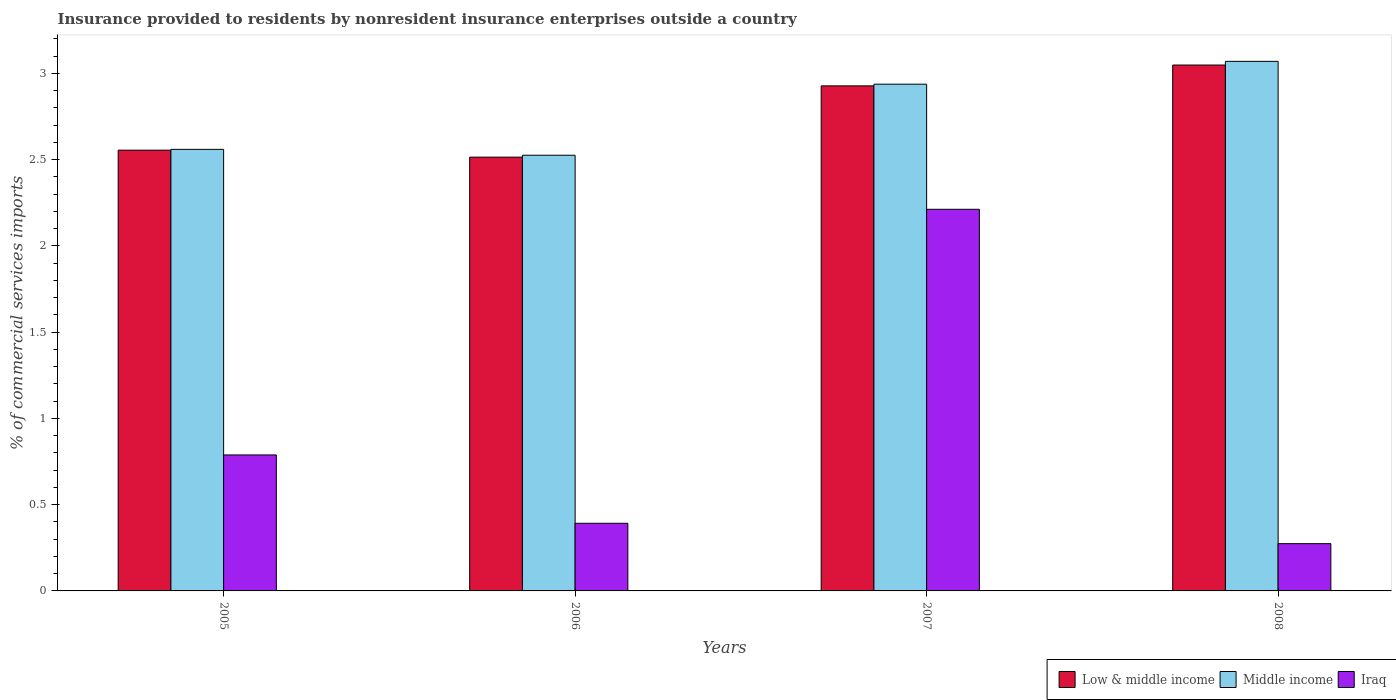Are the number of bars per tick equal to the number of legend labels?
Make the answer very short. Yes. How many bars are there on the 3rd tick from the right?
Offer a very short reply. 3. In how many cases, is the number of bars for a given year not equal to the number of legend labels?
Keep it short and to the point. 0. What is the Insurance provided to residents in Iraq in 2008?
Keep it short and to the point. 0.27. Across all years, what is the maximum Insurance provided to residents in Middle income?
Offer a very short reply. 3.07. Across all years, what is the minimum Insurance provided to residents in Low & middle income?
Your answer should be compact. 2.51. What is the total Insurance provided to residents in Middle income in the graph?
Keep it short and to the point. 11.09. What is the difference between the Insurance provided to residents in Middle income in 2006 and that in 2008?
Provide a succinct answer. -0.54. What is the difference between the Insurance provided to residents in Low & middle income in 2007 and the Insurance provided to residents in Iraq in 2005?
Ensure brevity in your answer.  2.14. What is the average Insurance provided to residents in Low & middle income per year?
Keep it short and to the point. 2.76. In the year 2005, what is the difference between the Insurance provided to residents in Iraq and Insurance provided to residents in Low & middle income?
Offer a very short reply. -1.77. What is the ratio of the Insurance provided to residents in Middle income in 2006 to that in 2007?
Offer a very short reply. 0.86. What is the difference between the highest and the second highest Insurance provided to residents in Low & middle income?
Offer a very short reply. 0.12. What is the difference between the highest and the lowest Insurance provided to residents in Middle income?
Offer a terse response. 0.54. In how many years, is the Insurance provided to residents in Low & middle income greater than the average Insurance provided to residents in Low & middle income taken over all years?
Make the answer very short. 2. Is the sum of the Insurance provided to residents in Iraq in 2007 and 2008 greater than the maximum Insurance provided to residents in Middle income across all years?
Offer a very short reply. No. How many bars are there?
Your response must be concise. 12. How many years are there in the graph?
Offer a terse response. 4. Does the graph contain any zero values?
Your response must be concise. No. Does the graph contain grids?
Ensure brevity in your answer.  No. How many legend labels are there?
Provide a short and direct response. 3. How are the legend labels stacked?
Your answer should be very brief. Horizontal. What is the title of the graph?
Offer a terse response. Insurance provided to residents by nonresident insurance enterprises outside a country. What is the label or title of the X-axis?
Your response must be concise. Years. What is the label or title of the Y-axis?
Offer a terse response. % of commercial services imports. What is the % of commercial services imports of Low & middle income in 2005?
Your answer should be compact. 2.56. What is the % of commercial services imports in Middle income in 2005?
Give a very brief answer. 2.56. What is the % of commercial services imports of Iraq in 2005?
Keep it short and to the point. 0.79. What is the % of commercial services imports of Low & middle income in 2006?
Provide a short and direct response. 2.51. What is the % of commercial services imports of Middle income in 2006?
Offer a terse response. 2.53. What is the % of commercial services imports of Iraq in 2006?
Your response must be concise. 0.39. What is the % of commercial services imports of Low & middle income in 2007?
Ensure brevity in your answer.  2.93. What is the % of commercial services imports in Middle income in 2007?
Your answer should be compact. 2.94. What is the % of commercial services imports of Iraq in 2007?
Your response must be concise. 2.21. What is the % of commercial services imports of Low & middle income in 2008?
Offer a terse response. 3.05. What is the % of commercial services imports of Middle income in 2008?
Ensure brevity in your answer.  3.07. What is the % of commercial services imports of Iraq in 2008?
Provide a short and direct response. 0.27. Across all years, what is the maximum % of commercial services imports in Low & middle income?
Offer a terse response. 3.05. Across all years, what is the maximum % of commercial services imports of Middle income?
Offer a very short reply. 3.07. Across all years, what is the maximum % of commercial services imports of Iraq?
Your answer should be very brief. 2.21. Across all years, what is the minimum % of commercial services imports of Low & middle income?
Keep it short and to the point. 2.51. Across all years, what is the minimum % of commercial services imports of Middle income?
Provide a short and direct response. 2.53. Across all years, what is the minimum % of commercial services imports in Iraq?
Offer a very short reply. 0.27. What is the total % of commercial services imports in Low & middle income in the graph?
Keep it short and to the point. 11.05. What is the total % of commercial services imports in Middle income in the graph?
Provide a short and direct response. 11.09. What is the total % of commercial services imports in Iraq in the graph?
Your response must be concise. 3.67. What is the difference between the % of commercial services imports in Low & middle income in 2005 and that in 2006?
Make the answer very short. 0.04. What is the difference between the % of commercial services imports in Middle income in 2005 and that in 2006?
Provide a short and direct response. 0.03. What is the difference between the % of commercial services imports in Iraq in 2005 and that in 2006?
Your answer should be compact. 0.4. What is the difference between the % of commercial services imports in Low & middle income in 2005 and that in 2007?
Give a very brief answer. -0.37. What is the difference between the % of commercial services imports of Middle income in 2005 and that in 2007?
Your response must be concise. -0.38. What is the difference between the % of commercial services imports of Iraq in 2005 and that in 2007?
Offer a terse response. -1.42. What is the difference between the % of commercial services imports of Low & middle income in 2005 and that in 2008?
Offer a very short reply. -0.49. What is the difference between the % of commercial services imports in Middle income in 2005 and that in 2008?
Offer a very short reply. -0.51. What is the difference between the % of commercial services imports of Iraq in 2005 and that in 2008?
Make the answer very short. 0.51. What is the difference between the % of commercial services imports of Low & middle income in 2006 and that in 2007?
Your answer should be compact. -0.41. What is the difference between the % of commercial services imports in Middle income in 2006 and that in 2007?
Your answer should be compact. -0.41. What is the difference between the % of commercial services imports of Iraq in 2006 and that in 2007?
Offer a terse response. -1.82. What is the difference between the % of commercial services imports in Low & middle income in 2006 and that in 2008?
Provide a succinct answer. -0.53. What is the difference between the % of commercial services imports in Middle income in 2006 and that in 2008?
Your answer should be compact. -0.54. What is the difference between the % of commercial services imports in Iraq in 2006 and that in 2008?
Offer a very short reply. 0.12. What is the difference between the % of commercial services imports in Low & middle income in 2007 and that in 2008?
Keep it short and to the point. -0.12. What is the difference between the % of commercial services imports in Middle income in 2007 and that in 2008?
Keep it short and to the point. -0.13. What is the difference between the % of commercial services imports in Iraq in 2007 and that in 2008?
Keep it short and to the point. 1.94. What is the difference between the % of commercial services imports in Low & middle income in 2005 and the % of commercial services imports in Middle income in 2006?
Make the answer very short. 0.03. What is the difference between the % of commercial services imports of Low & middle income in 2005 and the % of commercial services imports of Iraq in 2006?
Your answer should be compact. 2.16. What is the difference between the % of commercial services imports in Middle income in 2005 and the % of commercial services imports in Iraq in 2006?
Your answer should be compact. 2.17. What is the difference between the % of commercial services imports of Low & middle income in 2005 and the % of commercial services imports of Middle income in 2007?
Make the answer very short. -0.38. What is the difference between the % of commercial services imports of Low & middle income in 2005 and the % of commercial services imports of Iraq in 2007?
Offer a very short reply. 0.34. What is the difference between the % of commercial services imports in Middle income in 2005 and the % of commercial services imports in Iraq in 2007?
Keep it short and to the point. 0.35. What is the difference between the % of commercial services imports of Low & middle income in 2005 and the % of commercial services imports of Middle income in 2008?
Offer a very short reply. -0.51. What is the difference between the % of commercial services imports of Low & middle income in 2005 and the % of commercial services imports of Iraq in 2008?
Your response must be concise. 2.28. What is the difference between the % of commercial services imports of Middle income in 2005 and the % of commercial services imports of Iraq in 2008?
Your response must be concise. 2.29. What is the difference between the % of commercial services imports of Low & middle income in 2006 and the % of commercial services imports of Middle income in 2007?
Offer a terse response. -0.42. What is the difference between the % of commercial services imports in Low & middle income in 2006 and the % of commercial services imports in Iraq in 2007?
Your answer should be compact. 0.3. What is the difference between the % of commercial services imports of Middle income in 2006 and the % of commercial services imports of Iraq in 2007?
Provide a succinct answer. 0.31. What is the difference between the % of commercial services imports of Low & middle income in 2006 and the % of commercial services imports of Middle income in 2008?
Offer a very short reply. -0.56. What is the difference between the % of commercial services imports of Low & middle income in 2006 and the % of commercial services imports of Iraq in 2008?
Provide a short and direct response. 2.24. What is the difference between the % of commercial services imports in Middle income in 2006 and the % of commercial services imports in Iraq in 2008?
Ensure brevity in your answer.  2.25. What is the difference between the % of commercial services imports in Low & middle income in 2007 and the % of commercial services imports in Middle income in 2008?
Make the answer very short. -0.14. What is the difference between the % of commercial services imports of Low & middle income in 2007 and the % of commercial services imports of Iraq in 2008?
Provide a short and direct response. 2.65. What is the difference between the % of commercial services imports of Middle income in 2007 and the % of commercial services imports of Iraq in 2008?
Your response must be concise. 2.66. What is the average % of commercial services imports of Low & middle income per year?
Give a very brief answer. 2.76. What is the average % of commercial services imports of Middle income per year?
Offer a terse response. 2.77. What is the average % of commercial services imports of Iraq per year?
Your answer should be very brief. 0.92. In the year 2005, what is the difference between the % of commercial services imports of Low & middle income and % of commercial services imports of Middle income?
Provide a succinct answer. -0. In the year 2005, what is the difference between the % of commercial services imports in Low & middle income and % of commercial services imports in Iraq?
Offer a terse response. 1.77. In the year 2005, what is the difference between the % of commercial services imports in Middle income and % of commercial services imports in Iraq?
Offer a terse response. 1.77. In the year 2006, what is the difference between the % of commercial services imports in Low & middle income and % of commercial services imports in Middle income?
Give a very brief answer. -0.01. In the year 2006, what is the difference between the % of commercial services imports in Low & middle income and % of commercial services imports in Iraq?
Keep it short and to the point. 2.12. In the year 2006, what is the difference between the % of commercial services imports of Middle income and % of commercial services imports of Iraq?
Ensure brevity in your answer.  2.13. In the year 2007, what is the difference between the % of commercial services imports in Low & middle income and % of commercial services imports in Middle income?
Give a very brief answer. -0.01. In the year 2007, what is the difference between the % of commercial services imports in Low & middle income and % of commercial services imports in Iraq?
Make the answer very short. 0.72. In the year 2007, what is the difference between the % of commercial services imports in Middle income and % of commercial services imports in Iraq?
Your answer should be compact. 0.73. In the year 2008, what is the difference between the % of commercial services imports of Low & middle income and % of commercial services imports of Middle income?
Your answer should be very brief. -0.02. In the year 2008, what is the difference between the % of commercial services imports in Low & middle income and % of commercial services imports in Iraq?
Give a very brief answer. 2.77. In the year 2008, what is the difference between the % of commercial services imports of Middle income and % of commercial services imports of Iraq?
Provide a succinct answer. 2.8. What is the ratio of the % of commercial services imports of Low & middle income in 2005 to that in 2006?
Your answer should be compact. 1.02. What is the ratio of the % of commercial services imports in Middle income in 2005 to that in 2006?
Make the answer very short. 1.01. What is the ratio of the % of commercial services imports in Iraq in 2005 to that in 2006?
Offer a very short reply. 2.01. What is the ratio of the % of commercial services imports of Low & middle income in 2005 to that in 2007?
Your answer should be very brief. 0.87. What is the ratio of the % of commercial services imports in Middle income in 2005 to that in 2007?
Offer a very short reply. 0.87. What is the ratio of the % of commercial services imports in Iraq in 2005 to that in 2007?
Your response must be concise. 0.36. What is the ratio of the % of commercial services imports in Low & middle income in 2005 to that in 2008?
Your answer should be compact. 0.84. What is the ratio of the % of commercial services imports of Middle income in 2005 to that in 2008?
Your answer should be very brief. 0.83. What is the ratio of the % of commercial services imports in Iraq in 2005 to that in 2008?
Provide a succinct answer. 2.88. What is the ratio of the % of commercial services imports in Low & middle income in 2006 to that in 2007?
Your response must be concise. 0.86. What is the ratio of the % of commercial services imports of Middle income in 2006 to that in 2007?
Your answer should be compact. 0.86. What is the ratio of the % of commercial services imports in Iraq in 2006 to that in 2007?
Ensure brevity in your answer.  0.18. What is the ratio of the % of commercial services imports of Low & middle income in 2006 to that in 2008?
Provide a short and direct response. 0.82. What is the ratio of the % of commercial services imports in Middle income in 2006 to that in 2008?
Give a very brief answer. 0.82. What is the ratio of the % of commercial services imports in Iraq in 2006 to that in 2008?
Make the answer very short. 1.43. What is the ratio of the % of commercial services imports of Low & middle income in 2007 to that in 2008?
Offer a terse response. 0.96. What is the ratio of the % of commercial services imports of Middle income in 2007 to that in 2008?
Give a very brief answer. 0.96. What is the ratio of the % of commercial services imports in Iraq in 2007 to that in 2008?
Your answer should be very brief. 8.07. What is the difference between the highest and the second highest % of commercial services imports in Low & middle income?
Provide a succinct answer. 0.12. What is the difference between the highest and the second highest % of commercial services imports of Middle income?
Your answer should be very brief. 0.13. What is the difference between the highest and the second highest % of commercial services imports in Iraq?
Make the answer very short. 1.42. What is the difference between the highest and the lowest % of commercial services imports in Low & middle income?
Your answer should be compact. 0.53. What is the difference between the highest and the lowest % of commercial services imports of Middle income?
Give a very brief answer. 0.54. What is the difference between the highest and the lowest % of commercial services imports in Iraq?
Your answer should be compact. 1.94. 